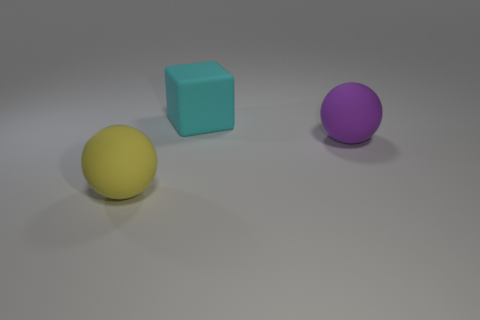Add 1 big purple rubber spheres. How many objects exist? 4 Subtract all blocks. How many objects are left? 2 Subtract all large yellow rubber objects. Subtract all large purple cylinders. How many objects are left? 2 Add 3 rubber things. How many rubber things are left? 6 Add 3 yellow spheres. How many yellow spheres exist? 4 Subtract 1 cyan cubes. How many objects are left? 2 